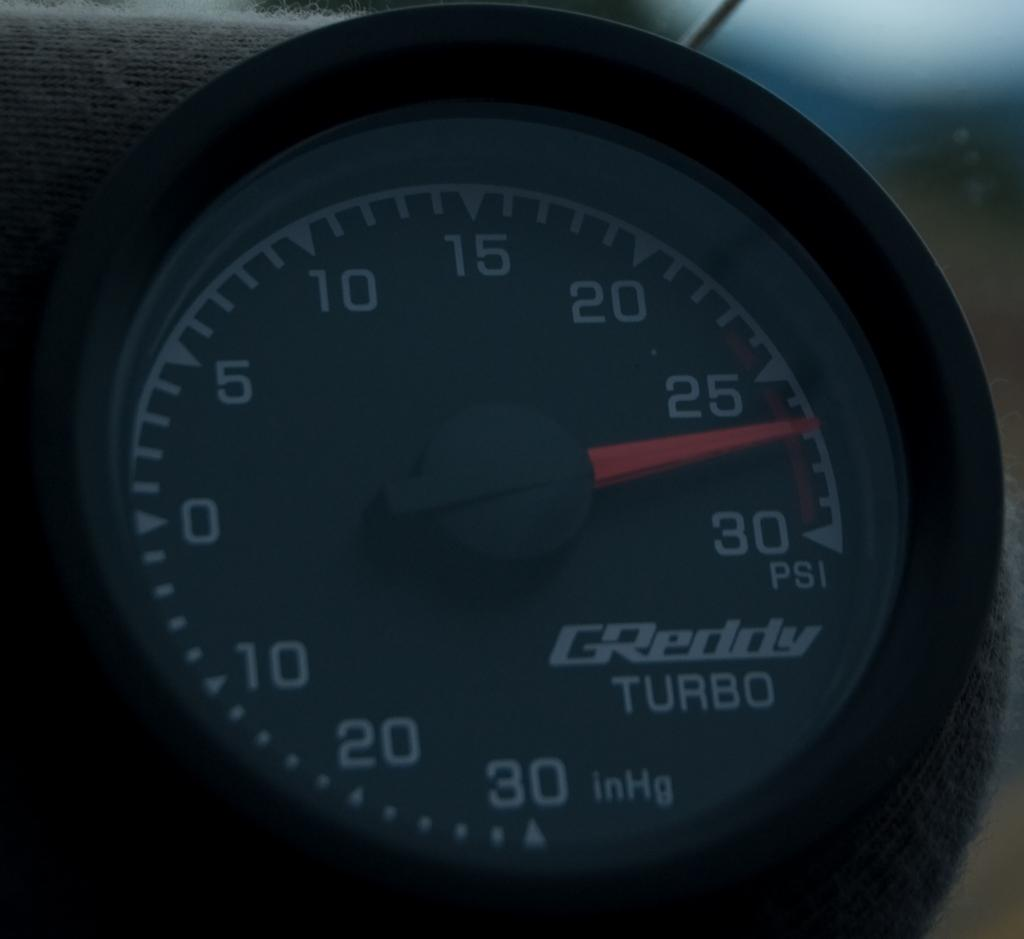What is the main object in the image? There is a speedometer in the image. What is written on the speedometer? The speedometer has a name on it, "greddy turbo." How does the speedometer increase the speed of the head in the image? The speedometer does not increase the speed of a head, as it is an instrument used to measure the speed of a vehicle. 